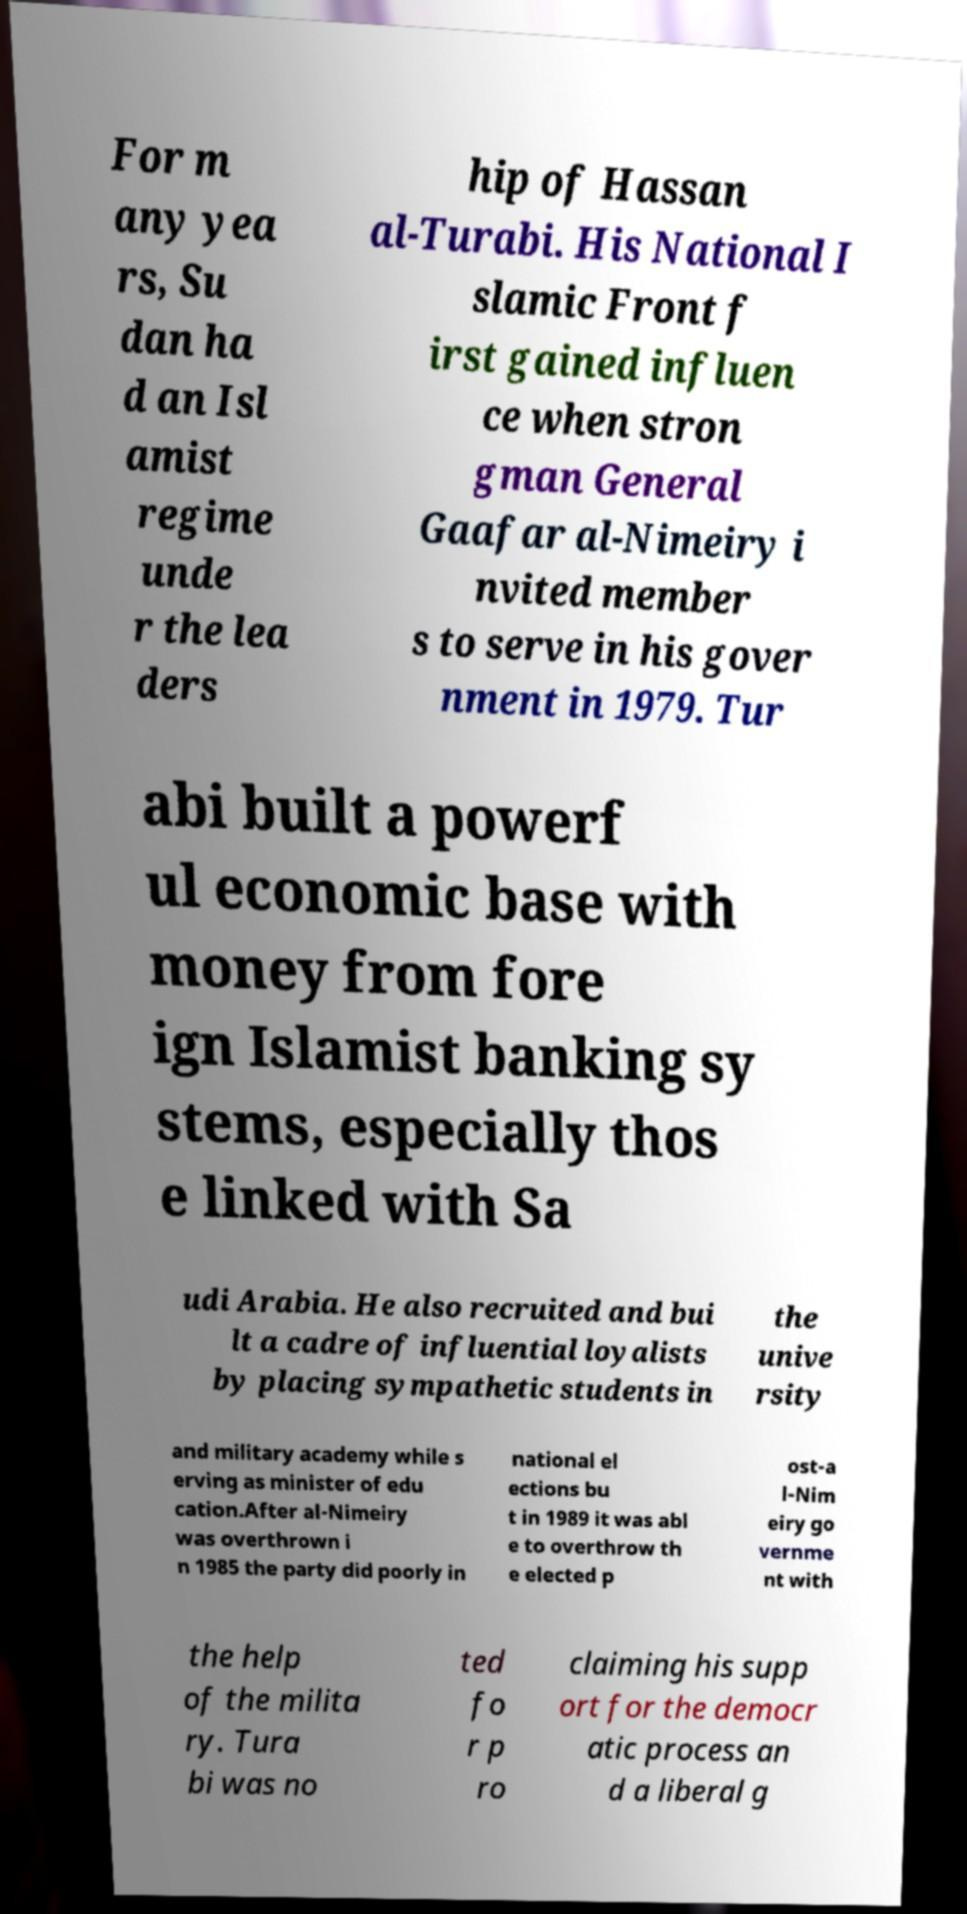Please read and relay the text visible in this image. What does it say? For m any yea rs, Su dan ha d an Isl amist regime unde r the lea ders hip of Hassan al-Turabi. His National I slamic Front f irst gained influen ce when stron gman General Gaafar al-Nimeiry i nvited member s to serve in his gover nment in 1979. Tur abi built a powerf ul economic base with money from fore ign Islamist banking sy stems, especially thos e linked with Sa udi Arabia. He also recruited and bui lt a cadre of influential loyalists by placing sympathetic students in the unive rsity and military academy while s erving as minister of edu cation.After al-Nimeiry was overthrown i n 1985 the party did poorly in national el ections bu t in 1989 it was abl e to overthrow th e elected p ost-a l-Nim eiry go vernme nt with the help of the milita ry. Tura bi was no ted fo r p ro claiming his supp ort for the democr atic process an d a liberal g 